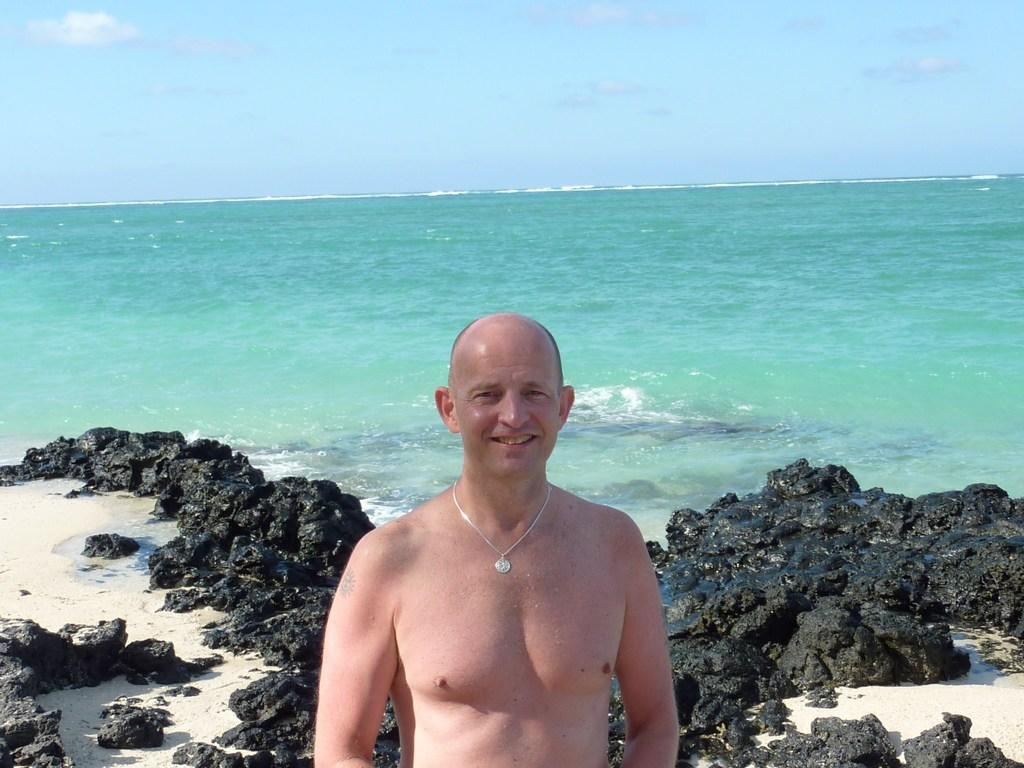Where was the image taken? The image is clicked outside the city. What is the main subject in the foreground of the image? There is a man in the foreground of the image. What is the man doing in the image? The man is standing and smiling. What can be seen in the background of the image? There are rocks, a water body, and the sky visible in the background of the image. What type of news can be heard in the image? There is no indication of any news or audio source in the image, so it cannot be determined. --- Facts: 1. There is a car in the image. 2. The car is red. 3. The car has four wheels. 4. There is a road in the image. 5. The road is paved. 6. There are trees on the side of the road. Absurd Topics: parrot, dance, ocean Conversation: What is the main subject of the image? The main subject of the image is a car. What color is the car? The car is red. How many wheels does the car have? The car has four wheels. What is visible in the background of the image? There is a road and trees on the side of the road visible in the image. What type of road is shown in the image? The road is paved. Reasoning: Let's think step by step in order to produce the conversation. We start by identifying the main subject of the image, which is the car. Then, we describe its color and the number of wheels it has. Next, we expand the conversation to include the background elements, such as the road and trees. Finally, we provide a detail about the road, which is that it is paved. Absurd Question/Answer: Can you hear the parrot singing in the image? There is no parrot or any sound source present in the image, so it cannot be determined. --- Facts: 1. There is a group of people in the image. 2. The people are wearing hats. 3. The people are holding hands. 4. There is a river in the background of the image. 5. The river is flowing. Absurd Topics: fireworks, piano, elephant Conversation: What is the main subject of the image? The main subject of the image is a group of people. What are the people wearing in the image? The people are wearing hats. What are the people doing in the image? The people are holding hands. What can be seen in the background of the image? There is a river in the background of the image. What is the river doing in the image? The river is flowing. Reasoning: Let's think step by step in order to produce the conversation 